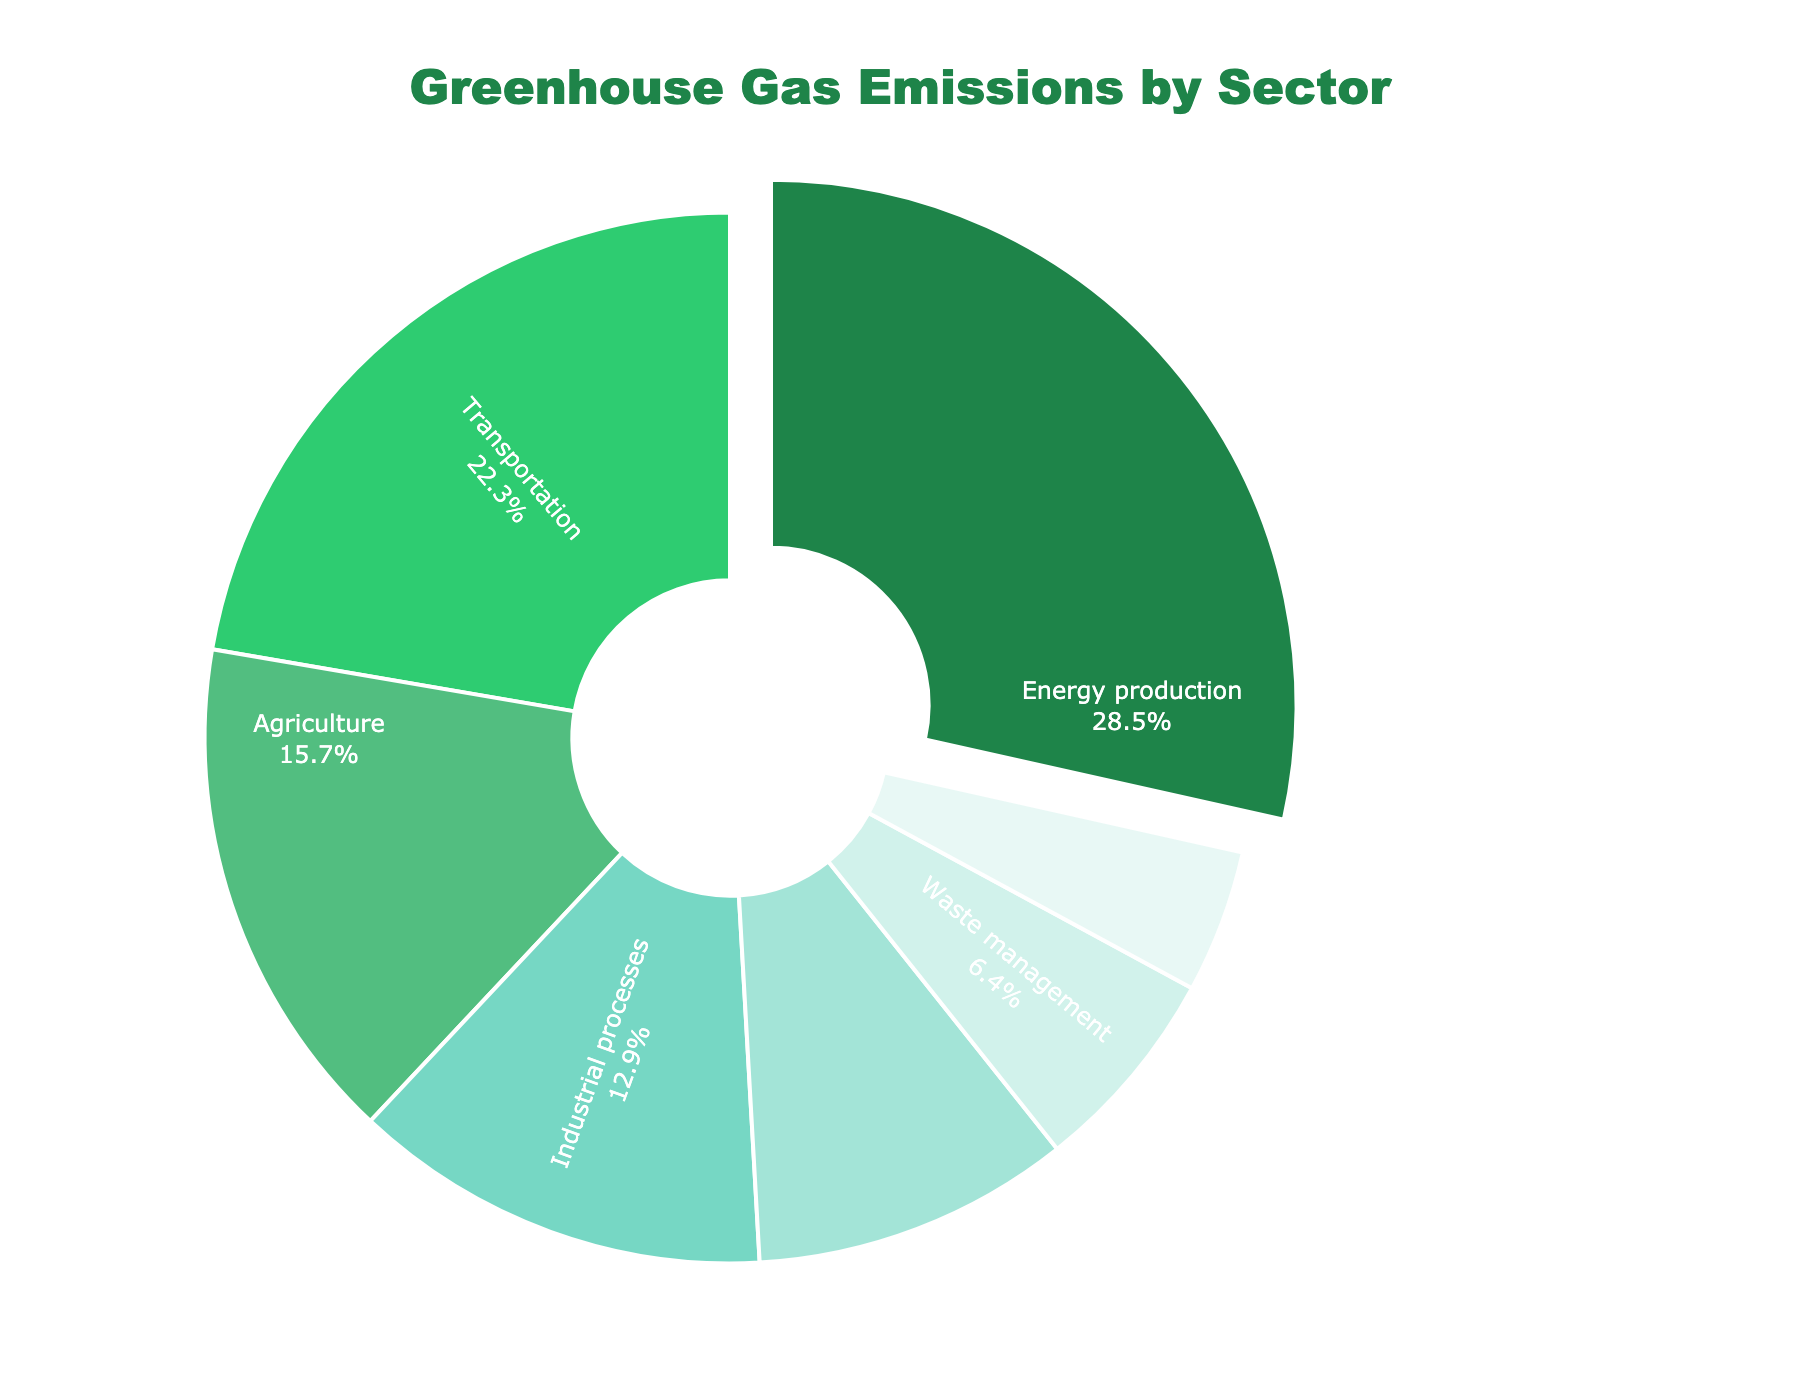Which sector contributes the highest percentage of greenhouse gas emissions? Look at the pie chart and identify the sector with the largest slice.
Answer: Energy production Which two sectors combined contribute over 50% to greenhouse gas emissions? Sum the percentages of the largest sectors and check if their combined value exceeds 50%.
Answer: Energy production and Transportation Is the percentage of emissions from the Transportation sector greater than or less than the percentage from Industrial processes? Compare the slices of Transportation (22.3%) and Industrial processes (12.9%).
Answer: Greater than How much more does the Energy production sector contribute compared to Agriculture? Subtract the percentage of Agriculture from Energy production: 28.5% - 15.7%.
Answer: 12.8% What is the proportion of greenhouse gas emissions from sectors excluding Energy production and Transportation? Sum the percentages of all sectors except Energy production (28.5%) and Transportation (22.3%): 15.7% + 12.9% + 9.8% + 6.4% + 4.4%.
Answer: 49.2% Which sector has the smallest contribution to greenhouse gas emissions, and what is its percentage? Identify the smallest slice in the pie chart and note its percentage.
Answer: Land use change and forestry, 4.4% Which sector's emissions are closest in percentage to those from Residential and commercial buildings? Compare the percentages of Residential and commercial buildings (9.8%) with the other sectors.
Answer: Industrial processes, 12.9% What's the combined percentage of greenhouse gas emissions from Waste management and Land use change and forestry? Sum the percentages of Waste management (6.4%) and Land use change and forestry (4.4%).
Answer: 10.8% Is the percentage of emissions from Agriculture greater than the sum of emissions from Waste management and Land use change and forestry? Calculate the sum of Waste management (6.4%) and Land use change and forestry (4.4%), then compare it to Agriculture (15.7%).
Answer: Yes Which sector is represented in a green color in the pie chart, and what is its percentage? Identify the green-colored slice and note its percentage.
Answer: Energy production, 28.5% 